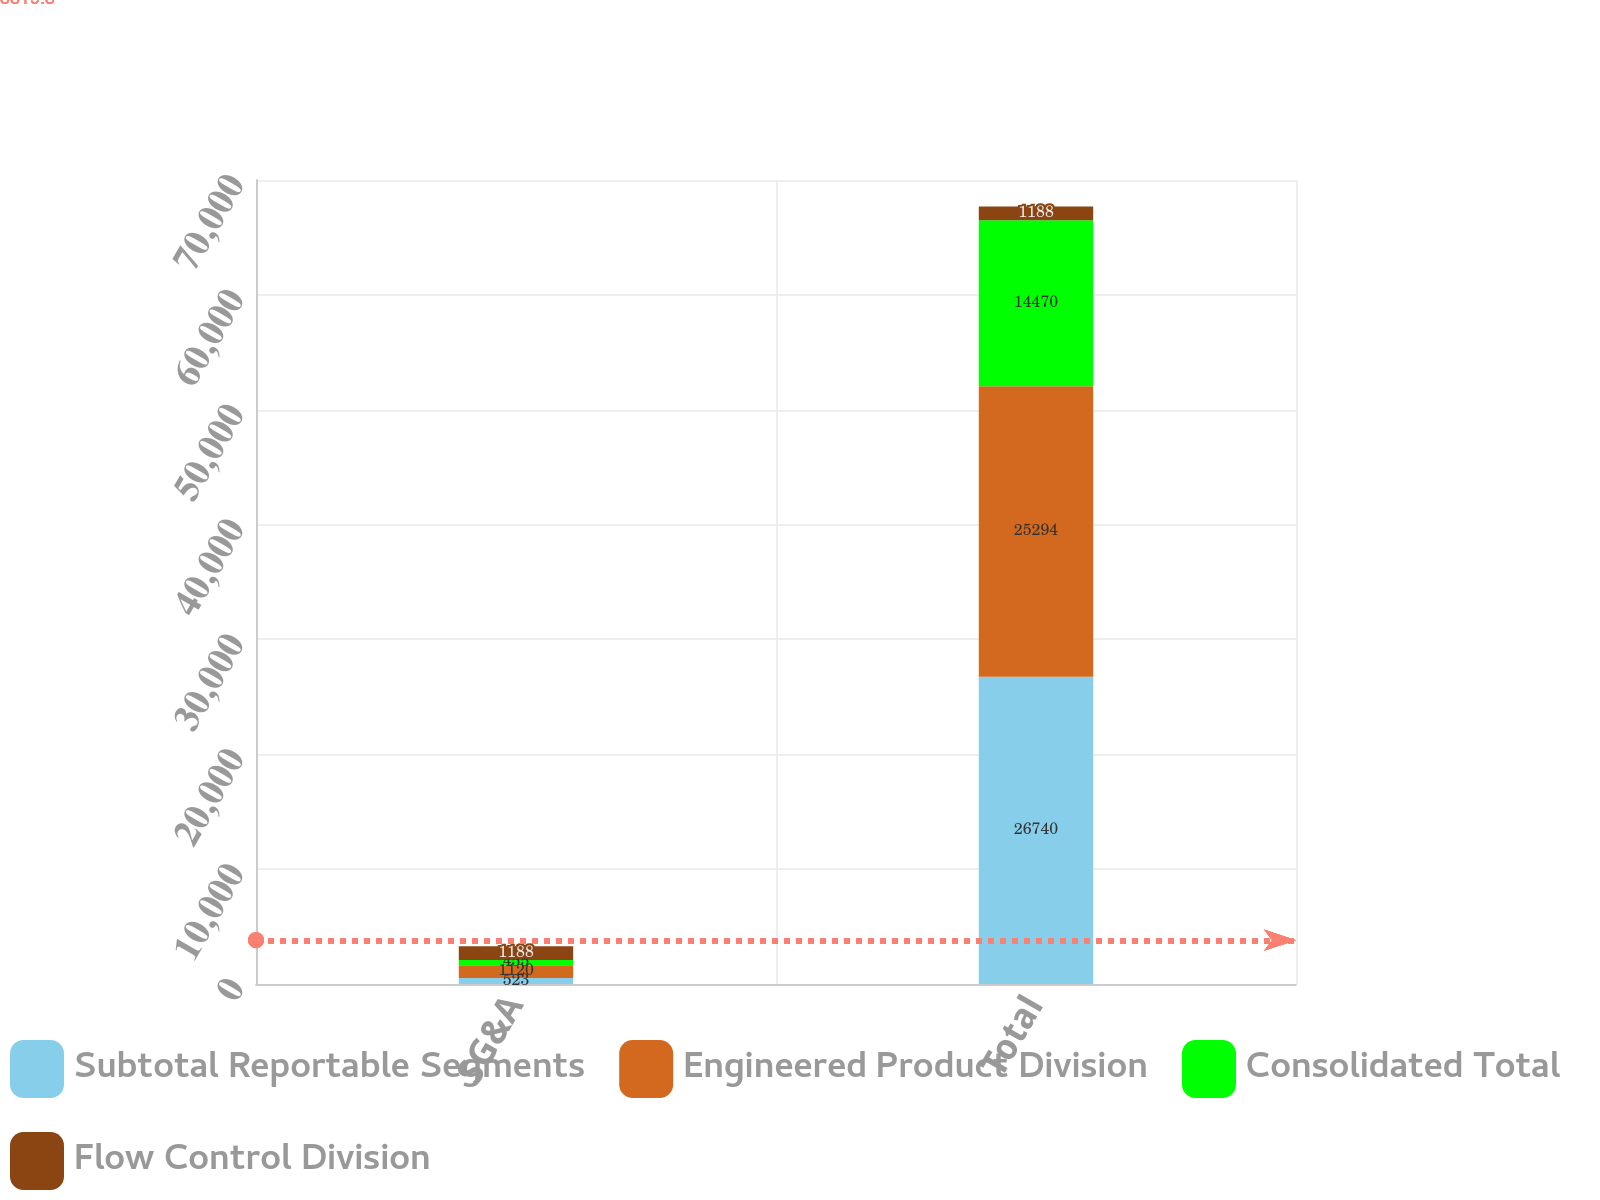<chart> <loc_0><loc_0><loc_500><loc_500><stacked_bar_chart><ecel><fcel>SG&A<fcel>Total<nl><fcel>Subtotal Reportable Segments<fcel>523<fcel>26740<nl><fcel>Engineered Product Division<fcel>1120<fcel>25294<nl><fcel>Consolidated Total<fcel>455<fcel>14470<nl><fcel>Flow Control Division<fcel>1188<fcel>1188<nl></chart> 